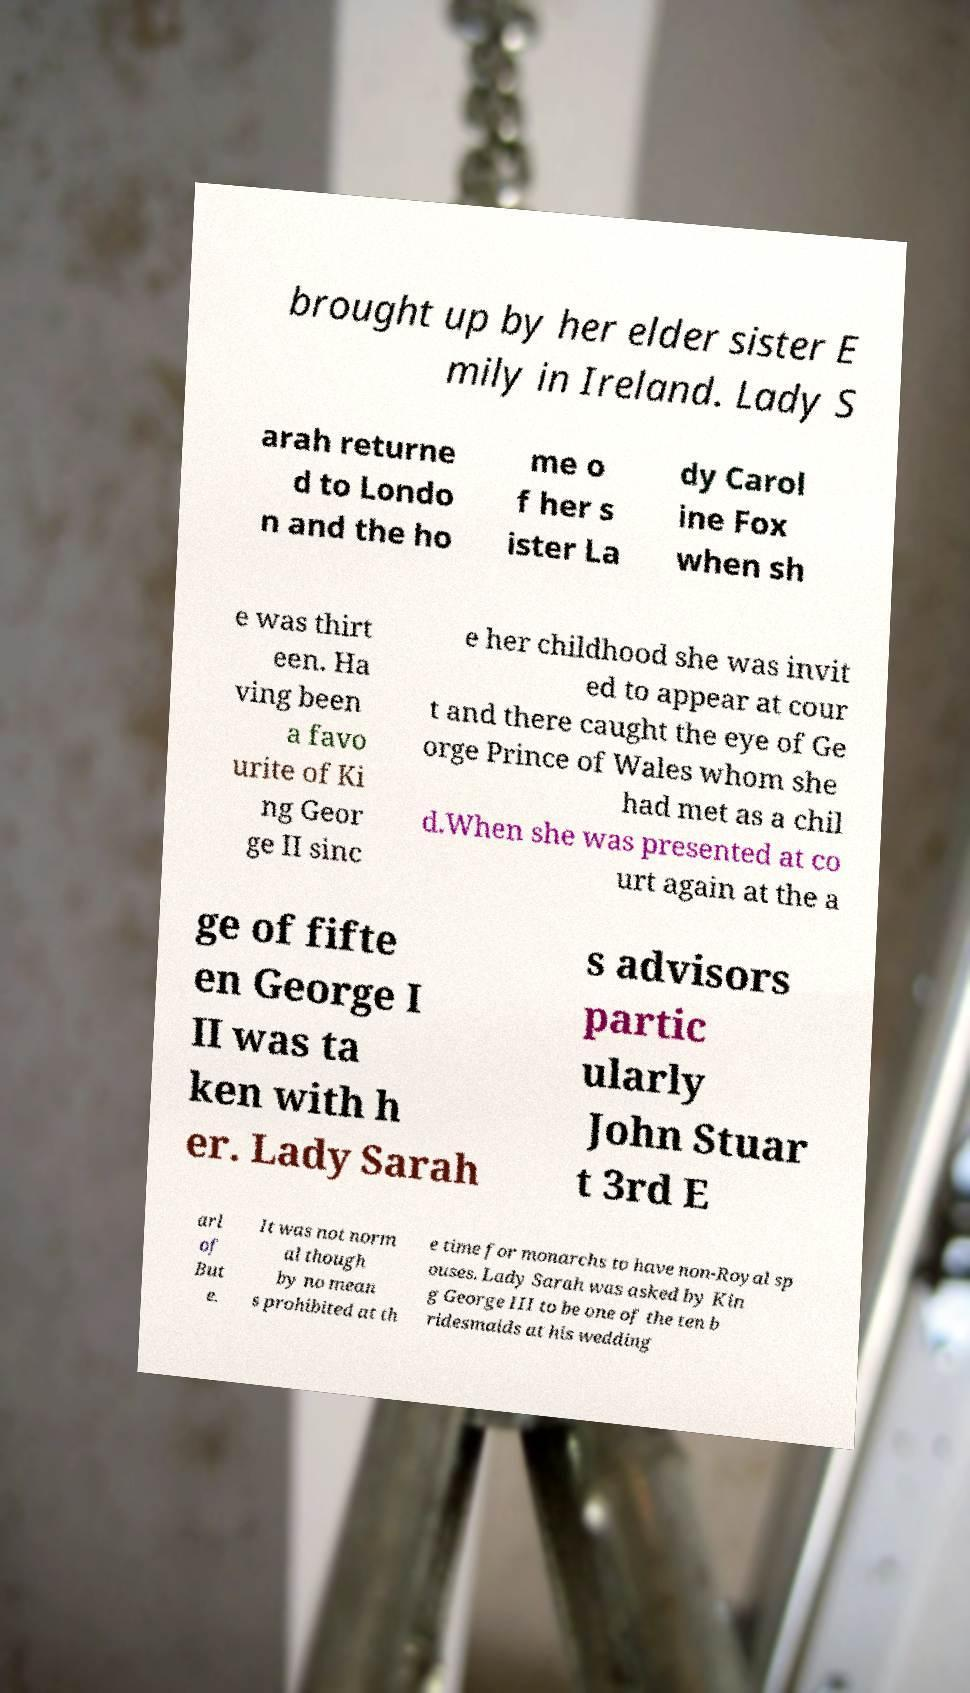Could you extract and type out the text from this image? brought up by her elder sister E mily in Ireland. Lady S arah returne d to Londo n and the ho me o f her s ister La dy Carol ine Fox when sh e was thirt een. Ha ving been a favo urite of Ki ng Geor ge II sinc e her childhood she was invit ed to appear at cour t and there caught the eye of Ge orge Prince of Wales whom she had met as a chil d.When she was presented at co urt again at the a ge of fifte en George I II was ta ken with h er. Lady Sarah s advisors partic ularly John Stuar t 3rd E arl of But e. It was not norm al though by no mean s prohibited at th e time for monarchs to have non-Royal sp ouses. Lady Sarah was asked by Kin g George III to be one of the ten b ridesmaids at his wedding 